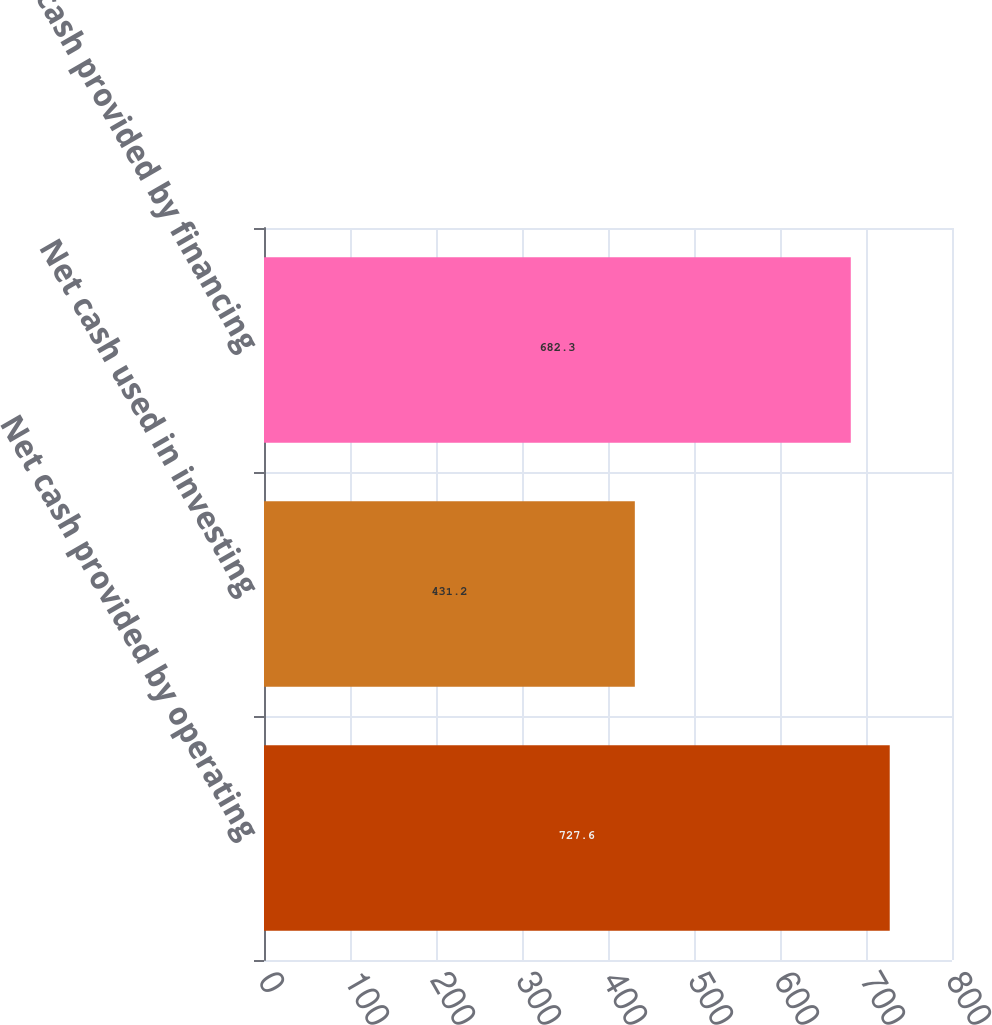<chart> <loc_0><loc_0><loc_500><loc_500><bar_chart><fcel>Net cash provided by operating<fcel>Net cash used in investing<fcel>Net cash provided by financing<nl><fcel>727.6<fcel>431.2<fcel>682.3<nl></chart> 